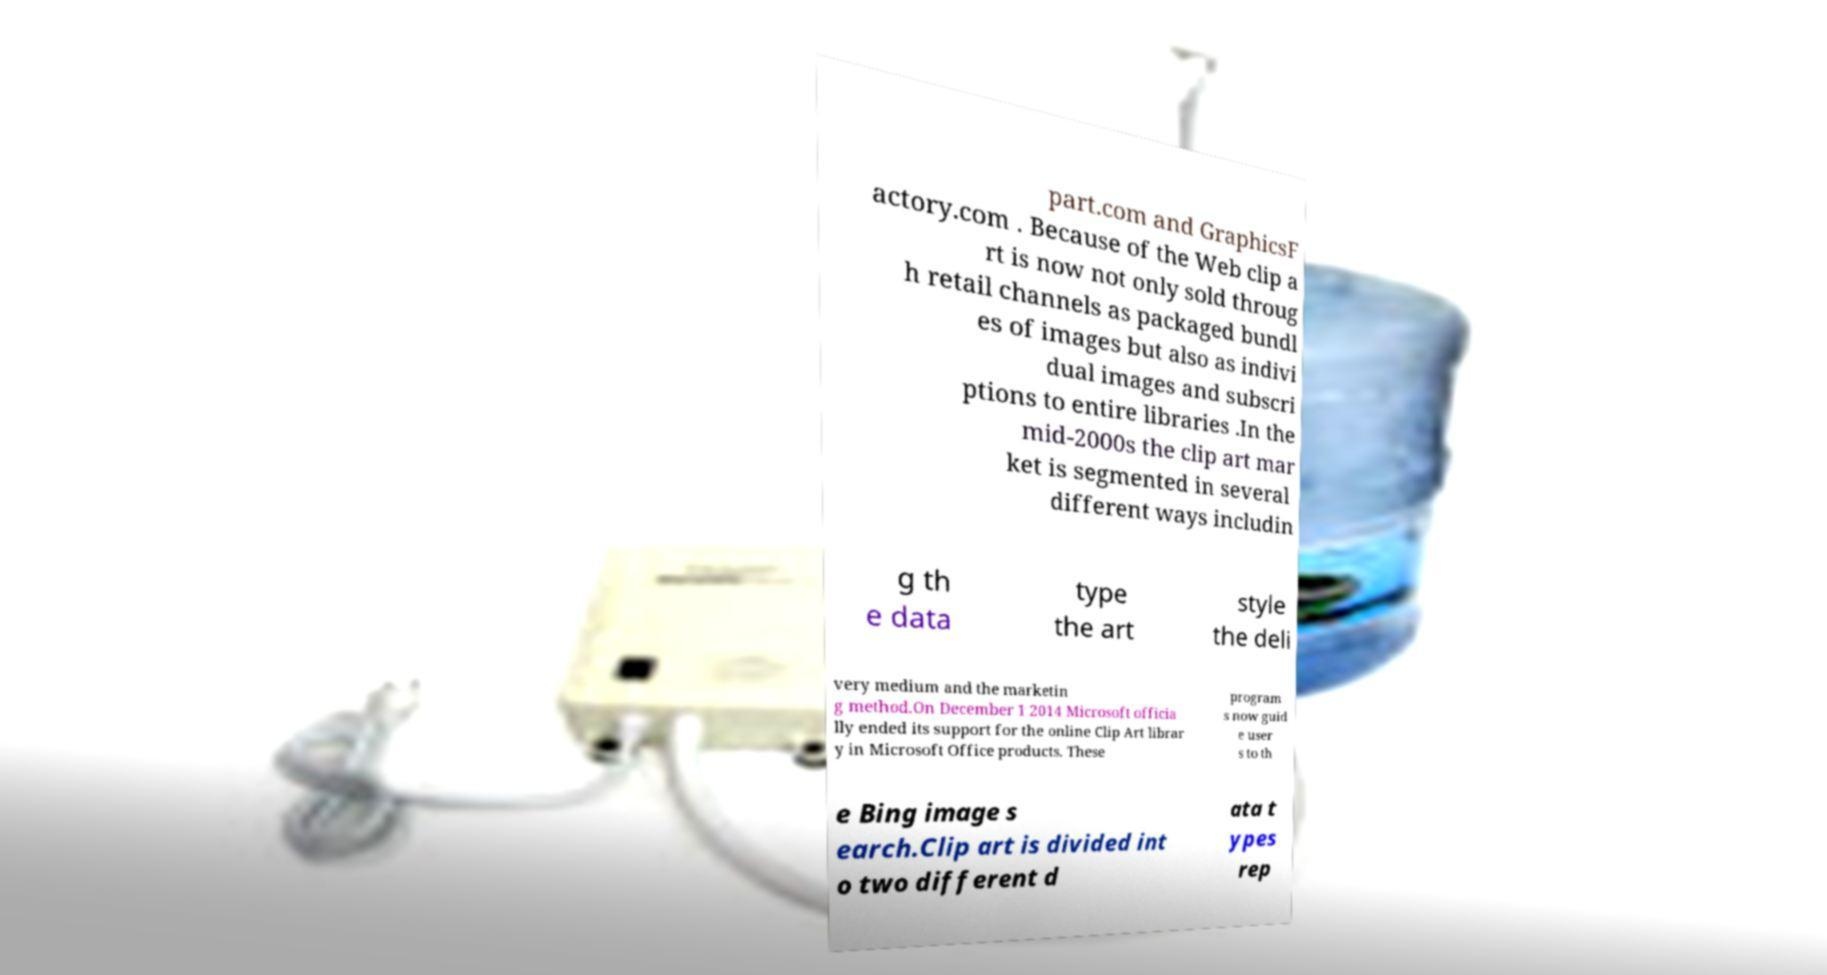Please read and relay the text visible in this image. What does it say? part.com and GraphicsF actory.com . Because of the Web clip a rt is now not only sold throug h retail channels as packaged bundl es of images but also as indivi dual images and subscri ptions to entire libraries .In the mid-2000s the clip art mar ket is segmented in several different ways includin g th e data type the art style the deli very medium and the marketin g method.On December 1 2014 Microsoft officia lly ended its support for the online Clip Art librar y in Microsoft Office products. These program s now guid e user s to th e Bing image s earch.Clip art is divided int o two different d ata t ypes rep 